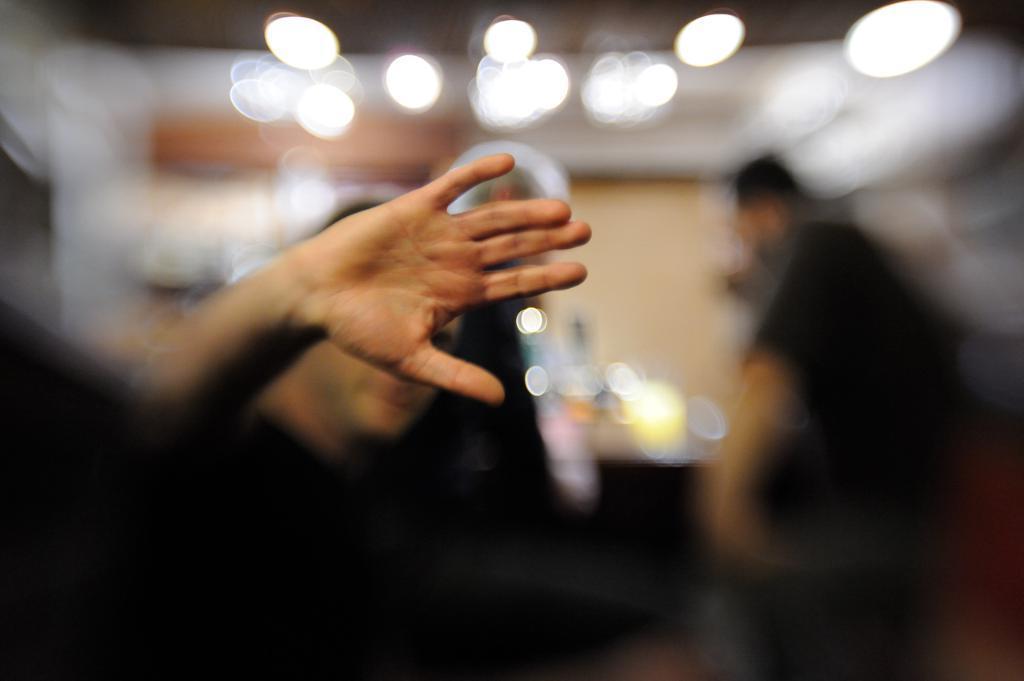Could you give a brief overview of what you see in this image? In this image we can see some person's hand and the background of the image is blurred. 